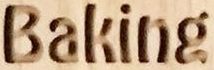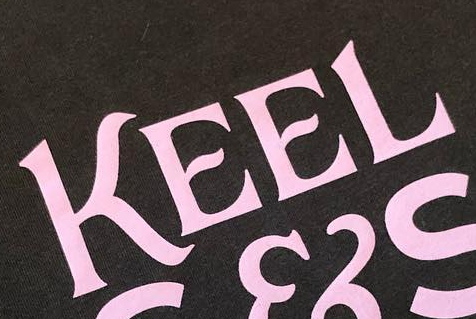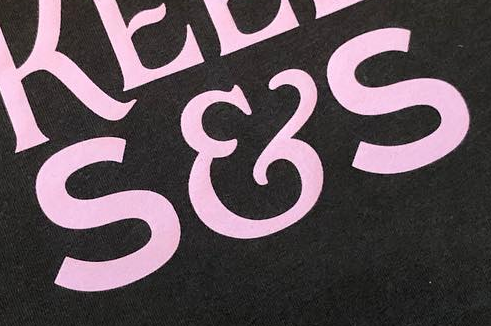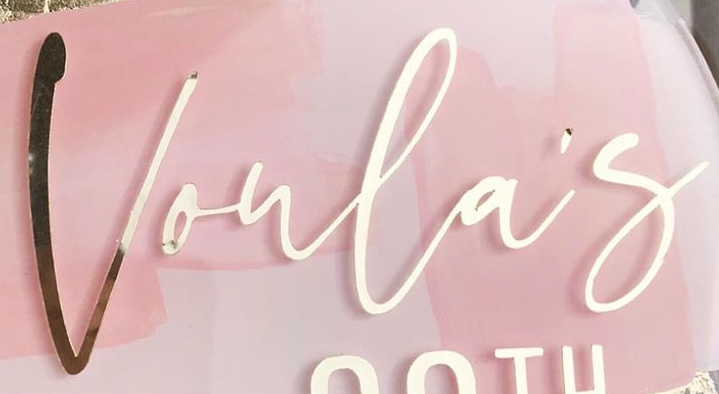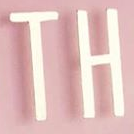What words are shown in these images in order, separated by a semicolon? Baking; KEEL; S&S; Voula's; TH 